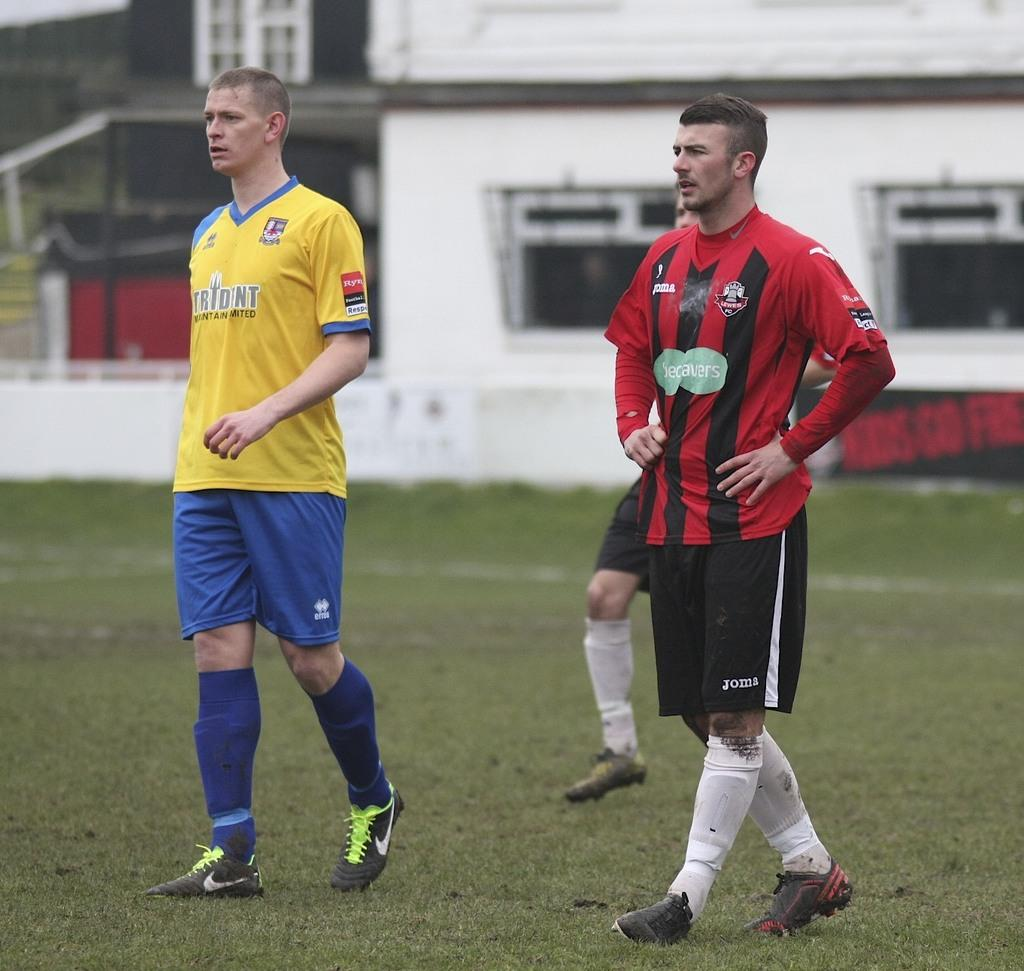<image>
Summarize the visual content of the image. A soccer player in a yellow Trident jersey walks next to a player with a red and black jersey who is wearing Joma shorts. 